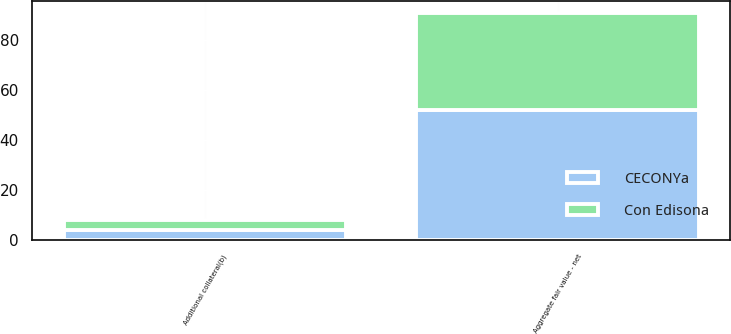Convert chart. <chart><loc_0><loc_0><loc_500><loc_500><stacked_bar_chart><ecel><fcel>Aggregate fair value - net<fcel>Additional collateral(b)<nl><fcel>CECONYa<fcel>52<fcel>4<nl><fcel>Con Edisona<fcel>39<fcel>4<nl></chart> 